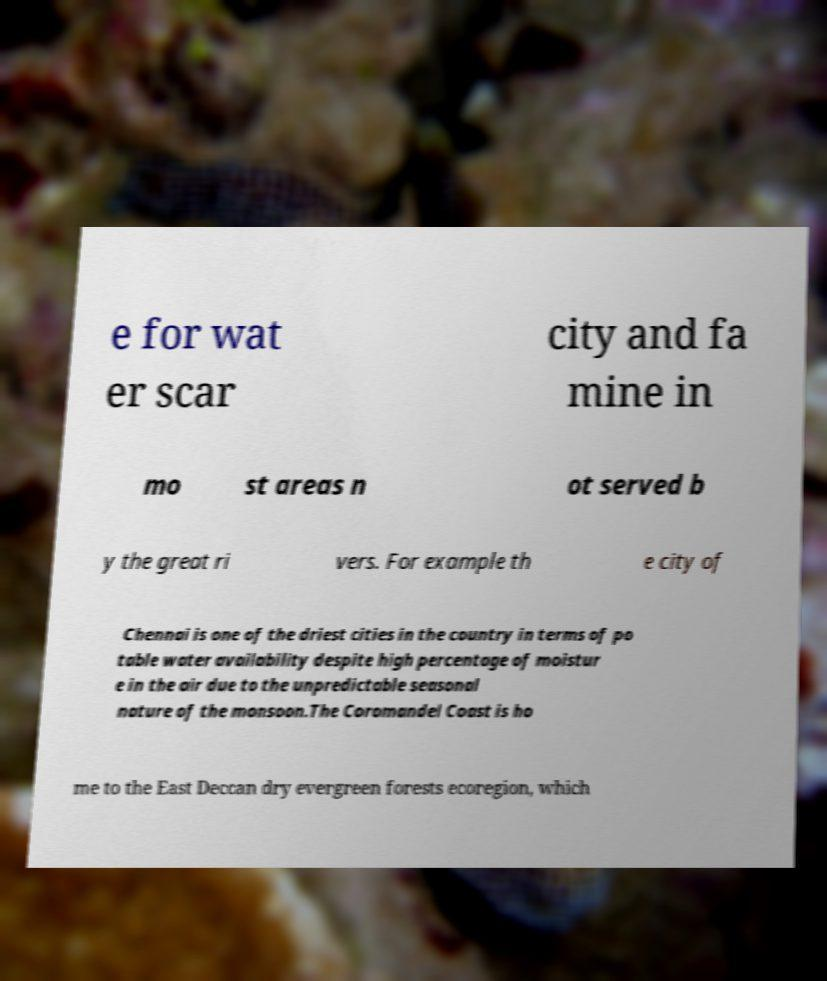I need the written content from this picture converted into text. Can you do that? e for wat er scar city and fa mine in mo st areas n ot served b y the great ri vers. For example th e city of Chennai is one of the driest cities in the country in terms of po table water availability despite high percentage of moistur e in the air due to the unpredictable seasonal nature of the monsoon.The Coromandel Coast is ho me to the East Deccan dry evergreen forests ecoregion, which 